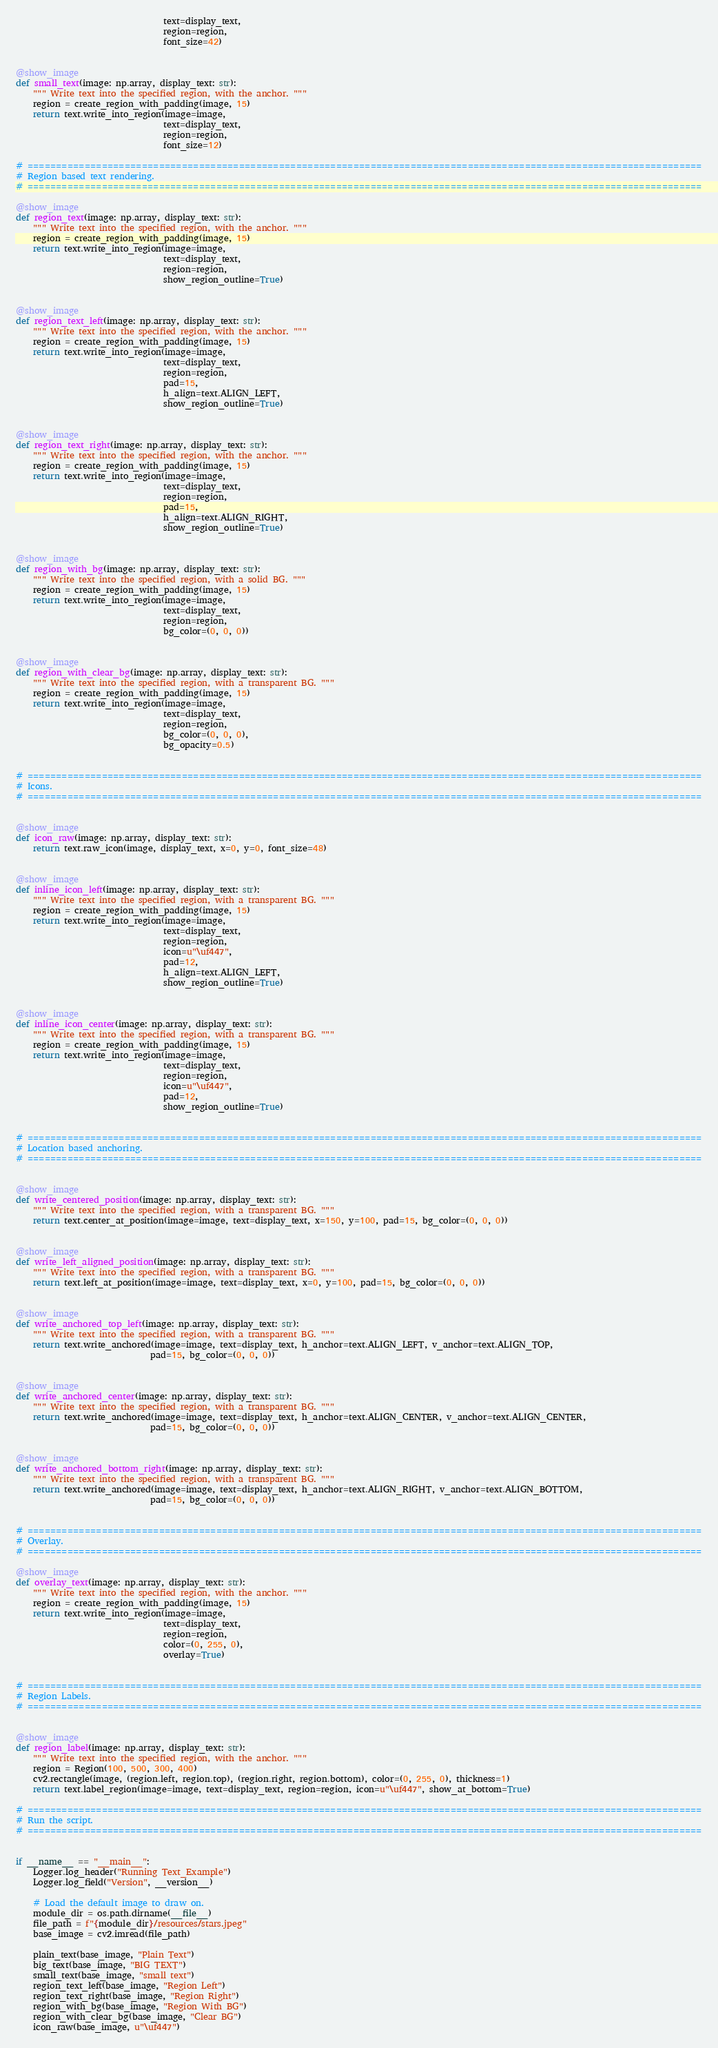<code> <loc_0><loc_0><loc_500><loc_500><_Python_>                                  text=display_text,
                                  region=region,
                                  font_size=42)


@show_image
def small_text(image: np.array, display_text: str):
    """ Write text into the specified region, with the anchor. """
    region = create_region_with_padding(image, 15)
    return text.write_into_region(image=image,
                                  text=display_text,
                                  region=region,
                                  font_size=12)

# ======================================================================================================================
# Region based text rendering.
# ======================================================================================================================

@show_image
def region_text(image: np.array, display_text: str):
    """ Write text into the specified region, with the anchor. """
    region = create_region_with_padding(image, 15)
    return text.write_into_region(image=image,
                                  text=display_text,
                                  region=region,
                                  show_region_outline=True)


@show_image
def region_text_left(image: np.array, display_text: str):
    """ Write text into the specified region, with the anchor. """
    region = create_region_with_padding(image, 15)
    return text.write_into_region(image=image,
                                  text=display_text,
                                  region=region,
                                  pad=15,
                                  h_align=text.ALIGN_LEFT,
                                  show_region_outline=True)


@show_image
def region_text_right(image: np.array, display_text: str):
    """ Write text into the specified region, with the anchor. """
    region = create_region_with_padding(image, 15)
    return text.write_into_region(image=image,
                                  text=display_text,
                                  region=region,
                                  pad=15,
                                  h_align=text.ALIGN_RIGHT,
                                  show_region_outline=True)


@show_image
def region_with_bg(image: np.array, display_text: str):
    """ Write text into the specified region, with a solid BG. """
    region = create_region_with_padding(image, 15)
    return text.write_into_region(image=image,
                                  text=display_text,
                                  region=region,
                                  bg_color=(0, 0, 0))


@show_image
def region_with_clear_bg(image: np.array, display_text: str):
    """ Write text into the specified region, with a transparent BG. """
    region = create_region_with_padding(image, 15)
    return text.write_into_region(image=image,
                                  text=display_text,
                                  region=region,
                                  bg_color=(0, 0, 0),
                                  bg_opacity=0.5)


# ======================================================================================================================
# Icons.
# ======================================================================================================================


@show_image
def icon_raw(image: np.array, display_text: str):
    return text.raw_icon(image, display_text, x=0, y=0, font_size=48)


@show_image
def inline_icon_left(image: np.array, display_text: str):
    """ Write text into the specified region, with a transparent BG. """
    region = create_region_with_padding(image, 15)
    return text.write_into_region(image=image,
                                  text=display_text,
                                  region=region,
                                  icon=u"\uf447",
                                  pad=12,
                                  h_align=text.ALIGN_LEFT,
                                  show_region_outline=True)


@show_image
def inline_icon_center(image: np.array, display_text: str):
    """ Write text into the specified region, with a transparent BG. """
    region = create_region_with_padding(image, 15)
    return text.write_into_region(image=image,
                                  text=display_text,
                                  region=region,
                                  icon=u"\uf447",
                                  pad=12,
                                  show_region_outline=True)


# ======================================================================================================================
# Location based anchoring.
# ======================================================================================================================


@show_image
def write_centered_position(image: np.array, display_text: str):
    """ Write text into the specified region, with a transparent BG. """
    return text.center_at_position(image=image, text=display_text, x=150, y=100, pad=15, bg_color=(0, 0, 0))


@show_image
def write_left_aligned_position(image: np.array, display_text: str):
    """ Write text into the specified region, with a transparent BG. """
    return text.left_at_position(image=image, text=display_text, x=0, y=100, pad=15, bg_color=(0, 0, 0))


@show_image
def write_anchored_top_left(image: np.array, display_text: str):
    """ Write text into the specified region, with a transparent BG. """
    return text.write_anchored(image=image, text=display_text, h_anchor=text.ALIGN_LEFT, v_anchor=text.ALIGN_TOP,
                               pad=15, bg_color=(0, 0, 0))


@show_image
def write_anchored_center(image: np.array, display_text: str):
    """ Write text into the specified region, with a transparent BG. """
    return text.write_anchored(image=image, text=display_text, h_anchor=text.ALIGN_CENTER, v_anchor=text.ALIGN_CENTER,
                               pad=15, bg_color=(0, 0, 0))


@show_image
def write_anchored_bottom_right(image: np.array, display_text: str):
    """ Write text into the specified region, with a transparent BG. """
    return text.write_anchored(image=image, text=display_text, h_anchor=text.ALIGN_RIGHT, v_anchor=text.ALIGN_BOTTOM,
                               pad=15, bg_color=(0, 0, 0))


# ======================================================================================================================
# Overlay.
# ======================================================================================================================

@show_image
def overlay_text(image: np.array, display_text: str):
    """ Write text into the specified region, with the anchor. """
    region = create_region_with_padding(image, 15)
    return text.write_into_region(image=image,
                                  text=display_text,
                                  region=region,
                                  color=(0, 255, 0),
                                  overlay=True)


# ======================================================================================================================
# Region Labels.
# ======================================================================================================================


@show_image
def region_label(image: np.array, display_text: str):
    """ Write text into the specified region, with the anchor. """
    region = Region(100, 500, 300, 400)
    cv2.rectangle(image, (region.left, region.top), (region.right, region.bottom), color=(0, 255, 0), thickness=1)
    return text.label_region(image=image, text=display_text, region=region, icon=u"\uf447", show_at_bottom=True)

# ======================================================================================================================
# Run the script.
# ======================================================================================================================


if __name__ == "__main__":
    Logger.log_header("Running Text_Example")
    Logger.log_field("Version", __version__)

    # Load the default image to draw on.
    module_dir = os.path.dirname(__file__)
    file_path = f"{module_dir}/resources/stars.jpeg"
    base_image = cv2.imread(file_path)

    plain_text(base_image, "Plain Text")
    big_text(base_image, "BIG TEXT")
    small_text(base_image, "small text")
    region_text_left(base_image, "Region Left")
    region_text_right(base_image, "Region Right")
    region_with_bg(base_image, "Region With BG")
    region_with_clear_bg(base_image, "Clear BG")
    icon_raw(base_image, u"\uf447")</code> 